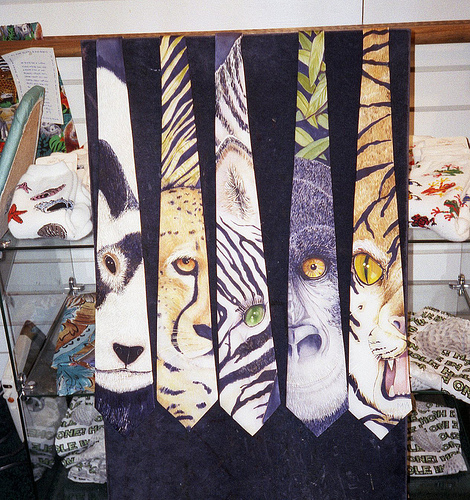Can you tell me which animals are depicted on these ties? Sure, the ties feature illustrations of a dog, a leopard, a zebra, a wolf, and a tiger, each with a distinct and vibrant portrayal. 